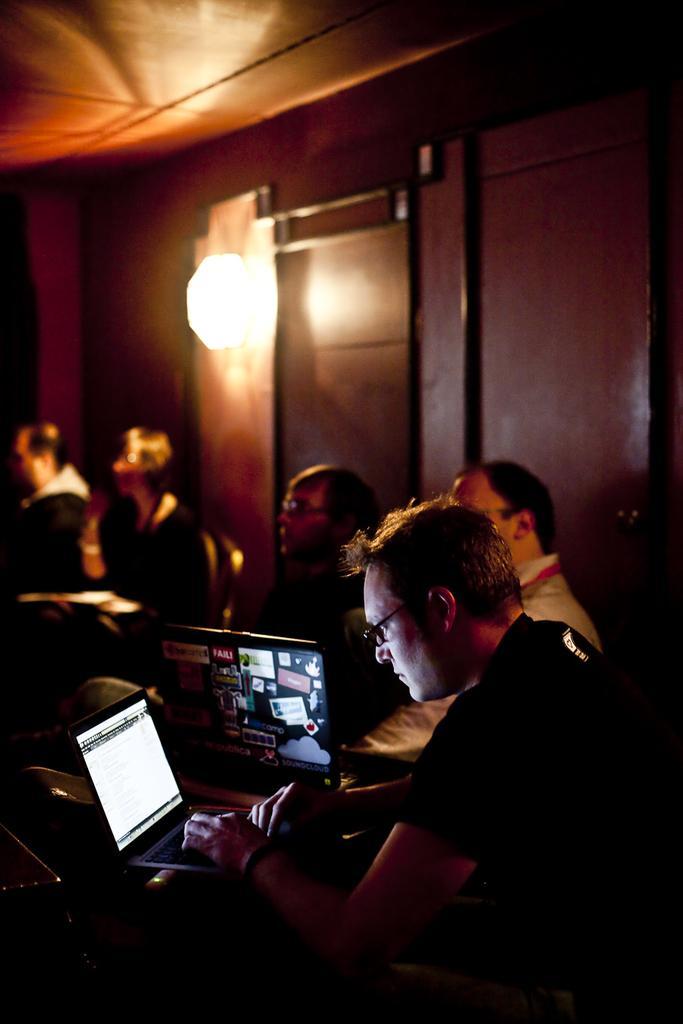How would you summarize this image in a sentence or two? In this image there is a man working on the laptop,there are group of people sitting,there is a light,there is a wall. 